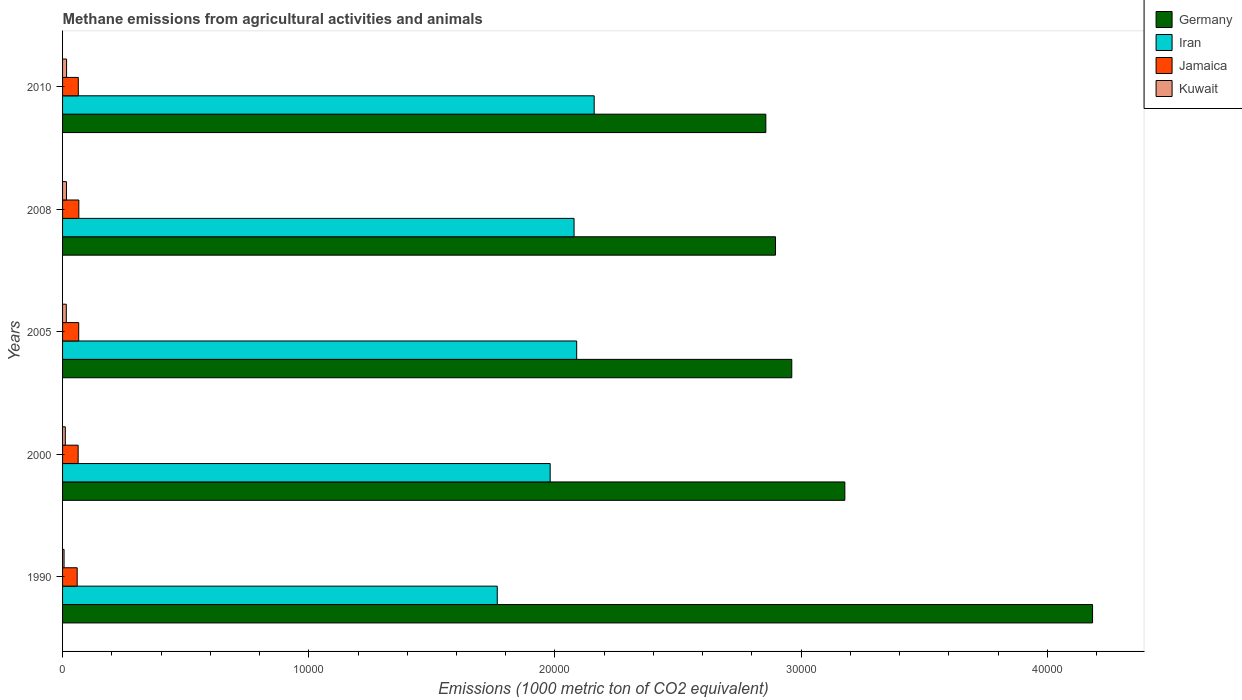Are the number of bars per tick equal to the number of legend labels?
Your response must be concise. Yes. How many bars are there on the 1st tick from the top?
Provide a short and direct response. 4. What is the amount of methane emitted in Kuwait in 2000?
Your answer should be very brief. 111.6. Across all years, what is the maximum amount of methane emitted in Germany?
Make the answer very short. 4.18e+04. Across all years, what is the minimum amount of methane emitted in Iran?
Your response must be concise. 1.77e+04. What is the total amount of methane emitted in Jamaica in the graph?
Make the answer very short. 3182.2. What is the difference between the amount of methane emitted in Iran in 1990 and that in 2000?
Give a very brief answer. -2149.4. What is the difference between the amount of methane emitted in Jamaica in 2010 and the amount of methane emitted in Kuwait in 2005?
Provide a short and direct response. 487.4. What is the average amount of methane emitted in Jamaica per year?
Provide a succinct answer. 636.44. In the year 2000, what is the difference between the amount of methane emitted in Iran and amount of methane emitted in Jamaica?
Give a very brief answer. 1.92e+04. In how many years, is the amount of methane emitted in Kuwait greater than 12000 1000 metric ton?
Give a very brief answer. 0. What is the ratio of the amount of methane emitted in Iran in 2000 to that in 2008?
Your answer should be compact. 0.95. What is the difference between the highest and the second highest amount of methane emitted in Jamaica?
Provide a short and direct response. 5.2. What is the difference between the highest and the lowest amount of methane emitted in Iran?
Your answer should be compact. 3937.1. Is the sum of the amount of methane emitted in Kuwait in 2005 and 2008 greater than the maximum amount of methane emitted in Iran across all years?
Ensure brevity in your answer.  No. Is it the case that in every year, the sum of the amount of methane emitted in Iran and amount of methane emitted in Germany is greater than the sum of amount of methane emitted in Kuwait and amount of methane emitted in Jamaica?
Your response must be concise. Yes. What does the 4th bar from the top in 1990 represents?
Offer a very short reply. Germany. What does the 1st bar from the bottom in 1990 represents?
Offer a very short reply. Germany. How many bars are there?
Provide a succinct answer. 20. Are the values on the major ticks of X-axis written in scientific E-notation?
Offer a terse response. No. Does the graph contain grids?
Offer a terse response. No. Where does the legend appear in the graph?
Ensure brevity in your answer.  Top right. What is the title of the graph?
Offer a terse response. Methane emissions from agricultural activities and animals. Does "South Asia" appear as one of the legend labels in the graph?
Your response must be concise. No. What is the label or title of the X-axis?
Your answer should be very brief. Emissions (1000 metric ton of CO2 equivalent). What is the Emissions (1000 metric ton of CO2 equivalent) of Germany in 1990?
Keep it short and to the point. 4.18e+04. What is the Emissions (1000 metric ton of CO2 equivalent) in Iran in 1990?
Your response must be concise. 1.77e+04. What is the Emissions (1000 metric ton of CO2 equivalent) in Jamaica in 1990?
Give a very brief answer. 593.6. What is the Emissions (1000 metric ton of CO2 equivalent) of Kuwait in 1990?
Provide a short and direct response. 60.5. What is the Emissions (1000 metric ton of CO2 equivalent) in Germany in 2000?
Provide a succinct answer. 3.18e+04. What is the Emissions (1000 metric ton of CO2 equivalent) in Iran in 2000?
Provide a succinct answer. 1.98e+04. What is the Emissions (1000 metric ton of CO2 equivalent) in Jamaica in 2000?
Your answer should be very brief. 632.9. What is the Emissions (1000 metric ton of CO2 equivalent) of Kuwait in 2000?
Provide a succinct answer. 111.6. What is the Emissions (1000 metric ton of CO2 equivalent) in Germany in 2005?
Provide a short and direct response. 2.96e+04. What is the Emissions (1000 metric ton of CO2 equivalent) in Iran in 2005?
Offer a very short reply. 2.09e+04. What is the Emissions (1000 metric ton of CO2 equivalent) in Jamaica in 2005?
Your answer should be compact. 655.6. What is the Emissions (1000 metric ton of CO2 equivalent) in Kuwait in 2005?
Your answer should be very brief. 151.9. What is the Emissions (1000 metric ton of CO2 equivalent) in Germany in 2008?
Give a very brief answer. 2.90e+04. What is the Emissions (1000 metric ton of CO2 equivalent) of Iran in 2008?
Ensure brevity in your answer.  2.08e+04. What is the Emissions (1000 metric ton of CO2 equivalent) in Jamaica in 2008?
Give a very brief answer. 660.8. What is the Emissions (1000 metric ton of CO2 equivalent) of Kuwait in 2008?
Offer a very short reply. 158. What is the Emissions (1000 metric ton of CO2 equivalent) in Germany in 2010?
Ensure brevity in your answer.  2.86e+04. What is the Emissions (1000 metric ton of CO2 equivalent) in Iran in 2010?
Keep it short and to the point. 2.16e+04. What is the Emissions (1000 metric ton of CO2 equivalent) of Jamaica in 2010?
Your response must be concise. 639.3. What is the Emissions (1000 metric ton of CO2 equivalent) of Kuwait in 2010?
Keep it short and to the point. 162.8. Across all years, what is the maximum Emissions (1000 metric ton of CO2 equivalent) of Germany?
Make the answer very short. 4.18e+04. Across all years, what is the maximum Emissions (1000 metric ton of CO2 equivalent) of Iran?
Keep it short and to the point. 2.16e+04. Across all years, what is the maximum Emissions (1000 metric ton of CO2 equivalent) in Jamaica?
Ensure brevity in your answer.  660.8. Across all years, what is the maximum Emissions (1000 metric ton of CO2 equivalent) in Kuwait?
Offer a terse response. 162.8. Across all years, what is the minimum Emissions (1000 metric ton of CO2 equivalent) in Germany?
Ensure brevity in your answer.  2.86e+04. Across all years, what is the minimum Emissions (1000 metric ton of CO2 equivalent) of Iran?
Offer a very short reply. 1.77e+04. Across all years, what is the minimum Emissions (1000 metric ton of CO2 equivalent) of Jamaica?
Make the answer very short. 593.6. Across all years, what is the minimum Emissions (1000 metric ton of CO2 equivalent) in Kuwait?
Offer a terse response. 60.5. What is the total Emissions (1000 metric ton of CO2 equivalent) of Germany in the graph?
Make the answer very short. 1.61e+05. What is the total Emissions (1000 metric ton of CO2 equivalent) of Iran in the graph?
Your answer should be very brief. 1.01e+05. What is the total Emissions (1000 metric ton of CO2 equivalent) of Jamaica in the graph?
Provide a succinct answer. 3182.2. What is the total Emissions (1000 metric ton of CO2 equivalent) of Kuwait in the graph?
Give a very brief answer. 644.8. What is the difference between the Emissions (1000 metric ton of CO2 equivalent) in Germany in 1990 and that in 2000?
Your answer should be very brief. 1.01e+04. What is the difference between the Emissions (1000 metric ton of CO2 equivalent) of Iran in 1990 and that in 2000?
Give a very brief answer. -2149.4. What is the difference between the Emissions (1000 metric ton of CO2 equivalent) in Jamaica in 1990 and that in 2000?
Make the answer very short. -39.3. What is the difference between the Emissions (1000 metric ton of CO2 equivalent) in Kuwait in 1990 and that in 2000?
Make the answer very short. -51.1. What is the difference between the Emissions (1000 metric ton of CO2 equivalent) of Germany in 1990 and that in 2005?
Keep it short and to the point. 1.22e+04. What is the difference between the Emissions (1000 metric ton of CO2 equivalent) of Iran in 1990 and that in 2005?
Make the answer very short. -3226.3. What is the difference between the Emissions (1000 metric ton of CO2 equivalent) in Jamaica in 1990 and that in 2005?
Make the answer very short. -62. What is the difference between the Emissions (1000 metric ton of CO2 equivalent) in Kuwait in 1990 and that in 2005?
Offer a very short reply. -91.4. What is the difference between the Emissions (1000 metric ton of CO2 equivalent) of Germany in 1990 and that in 2008?
Give a very brief answer. 1.29e+04. What is the difference between the Emissions (1000 metric ton of CO2 equivalent) in Iran in 1990 and that in 2008?
Keep it short and to the point. -3119.6. What is the difference between the Emissions (1000 metric ton of CO2 equivalent) of Jamaica in 1990 and that in 2008?
Provide a short and direct response. -67.2. What is the difference between the Emissions (1000 metric ton of CO2 equivalent) in Kuwait in 1990 and that in 2008?
Your response must be concise. -97.5. What is the difference between the Emissions (1000 metric ton of CO2 equivalent) in Germany in 1990 and that in 2010?
Offer a terse response. 1.33e+04. What is the difference between the Emissions (1000 metric ton of CO2 equivalent) of Iran in 1990 and that in 2010?
Your response must be concise. -3937.1. What is the difference between the Emissions (1000 metric ton of CO2 equivalent) in Jamaica in 1990 and that in 2010?
Give a very brief answer. -45.7. What is the difference between the Emissions (1000 metric ton of CO2 equivalent) of Kuwait in 1990 and that in 2010?
Provide a succinct answer. -102.3. What is the difference between the Emissions (1000 metric ton of CO2 equivalent) of Germany in 2000 and that in 2005?
Provide a short and direct response. 2155.4. What is the difference between the Emissions (1000 metric ton of CO2 equivalent) in Iran in 2000 and that in 2005?
Give a very brief answer. -1076.9. What is the difference between the Emissions (1000 metric ton of CO2 equivalent) in Jamaica in 2000 and that in 2005?
Your response must be concise. -22.7. What is the difference between the Emissions (1000 metric ton of CO2 equivalent) of Kuwait in 2000 and that in 2005?
Your answer should be compact. -40.3. What is the difference between the Emissions (1000 metric ton of CO2 equivalent) of Germany in 2000 and that in 2008?
Ensure brevity in your answer.  2816.4. What is the difference between the Emissions (1000 metric ton of CO2 equivalent) of Iran in 2000 and that in 2008?
Your answer should be compact. -970.2. What is the difference between the Emissions (1000 metric ton of CO2 equivalent) in Jamaica in 2000 and that in 2008?
Offer a very short reply. -27.9. What is the difference between the Emissions (1000 metric ton of CO2 equivalent) of Kuwait in 2000 and that in 2008?
Give a very brief answer. -46.4. What is the difference between the Emissions (1000 metric ton of CO2 equivalent) of Germany in 2000 and that in 2010?
Your response must be concise. 3209.1. What is the difference between the Emissions (1000 metric ton of CO2 equivalent) in Iran in 2000 and that in 2010?
Offer a very short reply. -1787.7. What is the difference between the Emissions (1000 metric ton of CO2 equivalent) of Kuwait in 2000 and that in 2010?
Provide a short and direct response. -51.2. What is the difference between the Emissions (1000 metric ton of CO2 equivalent) of Germany in 2005 and that in 2008?
Offer a terse response. 661. What is the difference between the Emissions (1000 metric ton of CO2 equivalent) of Iran in 2005 and that in 2008?
Offer a terse response. 106.7. What is the difference between the Emissions (1000 metric ton of CO2 equivalent) in Jamaica in 2005 and that in 2008?
Offer a terse response. -5.2. What is the difference between the Emissions (1000 metric ton of CO2 equivalent) in Germany in 2005 and that in 2010?
Your response must be concise. 1053.7. What is the difference between the Emissions (1000 metric ton of CO2 equivalent) of Iran in 2005 and that in 2010?
Provide a short and direct response. -710.8. What is the difference between the Emissions (1000 metric ton of CO2 equivalent) in Jamaica in 2005 and that in 2010?
Make the answer very short. 16.3. What is the difference between the Emissions (1000 metric ton of CO2 equivalent) in Germany in 2008 and that in 2010?
Provide a succinct answer. 392.7. What is the difference between the Emissions (1000 metric ton of CO2 equivalent) of Iran in 2008 and that in 2010?
Your response must be concise. -817.5. What is the difference between the Emissions (1000 metric ton of CO2 equivalent) of Kuwait in 2008 and that in 2010?
Provide a short and direct response. -4.8. What is the difference between the Emissions (1000 metric ton of CO2 equivalent) in Germany in 1990 and the Emissions (1000 metric ton of CO2 equivalent) in Iran in 2000?
Keep it short and to the point. 2.20e+04. What is the difference between the Emissions (1000 metric ton of CO2 equivalent) in Germany in 1990 and the Emissions (1000 metric ton of CO2 equivalent) in Jamaica in 2000?
Offer a very short reply. 4.12e+04. What is the difference between the Emissions (1000 metric ton of CO2 equivalent) of Germany in 1990 and the Emissions (1000 metric ton of CO2 equivalent) of Kuwait in 2000?
Your answer should be compact. 4.17e+04. What is the difference between the Emissions (1000 metric ton of CO2 equivalent) in Iran in 1990 and the Emissions (1000 metric ton of CO2 equivalent) in Jamaica in 2000?
Ensure brevity in your answer.  1.70e+04. What is the difference between the Emissions (1000 metric ton of CO2 equivalent) of Iran in 1990 and the Emissions (1000 metric ton of CO2 equivalent) of Kuwait in 2000?
Provide a succinct answer. 1.75e+04. What is the difference between the Emissions (1000 metric ton of CO2 equivalent) of Jamaica in 1990 and the Emissions (1000 metric ton of CO2 equivalent) of Kuwait in 2000?
Provide a succinct answer. 482. What is the difference between the Emissions (1000 metric ton of CO2 equivalent) of Germany in 1990 and the Emissions (1000 metric ton of CO2 equivalent) of Iran in 2005?
Offer a terse response. 2.10e+04. What is the difference between the Emissions (1000 metric ton of CO2 equivalent) in Germany in 1990 and the Emissions (1000 metric ton of CO2 equivalent) in Jamaica in 2005?
Offer a very short reply. 4.12e+04. What is the difference between the Emissions (1000 metric ton of CO2 equivalent) of Germany in 1990 and the Emissions (1000 metric ton of CO2 equivalent) of Kuwait in 2005?
Keep it short and to the point. 4.17e+04. What is the difference between the Emissions (1000 metric ton of CO2 equivalent) in Iran in 1990 and the Emissions (1000 metric ton of CO2 equivalent) in Jamaica in 2005?
Give a very brief answer. 1.70e+04. What is the difference between the Emissions (1000 metric ton of CO2 equivalent) of Iran in 1990 and the Emissions (1000 metric ton of CO2 equivalent) of Kuwait in 2005?
Provide a short and direct response. 1.75e+04. What is the difference between the Emissions (1000 metric ton of CO2 equivalent) of Jamaica in 1990 and the Emissions (1000 metric ton of CO2 equivalent) of Kuwait in 2005?
Ensure brevity in your answer.  441.7. What is the difference between the Emissions (1000 metric ton of CO2 equivalent) of Germany in 1990 and the Emissions (1000 metric ton of CO2 equivalent) of Iran in 2008?
Your answer should be very brief. 2.11e+04. What is the difference between the Emissions (1000 metric ton of CO2 equivalent) in Germany in 1990 and the Emissions (1000 metric ton of CO2 equivalent) in Jamaica in 2008?
Provide a succinct answer. 4.12e+04. What is the difference between the Emissions (1000 metric ton of CO2 equivalent) of Germany in 1990 and the Emissions (1000 metric ton of CO2 equivalent) of Kuwait in 2008?
Ensure brevity in your answer.  4.17e+04. What is the difference between the Emissions (1000 metric ton of CO2 equivalent) in Iran in 1990 and the Emissions (1000 metric ton of CO2 equivalent) in Jamaica in 2008?
Give a very brief answer. 1.70e+04. What is the difference between the Emissions (1000 metric ton of CO2 equivalent) of Iran in 1990 and the Emissions (1000 metric ton of CO2 equivalent) of Kuwait in 2008?
Your answer should be very brief. 1.75e+04. What is the difference between the Emissions (1000 metric ton of CO2 equivalent) of Jamaica in 1990 and the Emissions (1000 metric ton of CO2 equivalent) of Kuwait in 2008?
Offer a terse response. 435.6. What is the difference between the Emissions (1000 metric ton of CO2 equivalent) in Germany in 1990 and the Emissions (1000 metric ton of CO2 equivalent) in Iran in 2010?
Provide a succinct answer. 2.02e+04. What is the difference between the Emissions (1000 metric ton of CO2 equivalent) in Germany in 1990 and the Emissions (1000 metric ton of CO2 equivalent) in Jamaica in 2010?
Your answer should be very brief. 4.12e+04. What is the difference between the Emissions (1000 metric ton of CO2 equivalent) of Germany in 1990 and the Emissions (1000 metric ton of CO2 equivalent) of Kuwait in 2010?
Make the answer very short. 4.17e+04. What is the difference between the Emissions (1000 metric ton of CO2 equivalent) of Iran in 1990 and the Emissions (1000 metric ton of CO2 equivalent) of Jamaica in 2010?
Make the answer very short. 1.70e+04. What is the difference between the Emissions (1000 metric ton of CO2 equivalent) of Iran in 1990 and the Emissions (1000 metric ton of CO2 equivalent) of Kuwait in 2010?
Make the answer very short. 1.75e+04. What is the difference between the Emissions (1000 metric ton of CO2 equivalent) in Jamaica in 1990 and the Emissions (1000 metric ton of CO2 equivalent) in Kuwait in 2010?
Offer a terse response. 430.8. What is the difference between the Emissions (1000 metric ton of CO2 equivalent) of Germany in 2000 and the Emissions (1000 metric ton of CO2 equivalent) of Iran in 2005?
Provide a succinct answer. 1.09e+04. What is the difference between the Emissions (1000 metric ton of CO2 equivalent) of Germany in 2000 and the Emissions (1000 metric ton of CO2 equivalent) of Jamaica in 2005?
Provide a short and direct response. 3.11e+04. What is the difference between the Emissions (1000 metric ton of CO2 equivalent) in Germany in 2000 and the Emissions (1000 metric ton of CO2 equivalent) in Kuwait in 2005?
Provide a short and direct response. 3.16e+04. What is the difference between the Emissions (1000 metric ton of CO2 equivalent) in Iran in 2000 and the Emissions (1000 metric ton of CO2 equivalent) in Jamaica in 2005?
Offer a terse response. 1.91e+04. What is the difference between the Emissions (1000 metric ton of CO2 equivalent) of Iran in 2000 and the Emissions (1000 metric ton of CO2 equivalent) of Kuwait in 2005?
Ensure brevity in your answer.  1.97e+04. What is the difference between the Emissions (1000 metric ton of CO2 equivalent) in Jamaica in 2000 and the Emissions (1000 metric ton of CO2 equivalent) in Kuwait in 2005?
Give a very brief answer. 481. What is the difference between the Emissions (1000 metric ton of CO2 equivalent) of Germany in 2000 and the Emissions (1000 metric ton of CO2 equivalent) of Iran in 2008?
Provide a short and direct response. 1.10e+04. What is the difference between the Emissions (1000 metric ton of CO2 equivalent) in Germany in 2000 and the Emissions (1000 metric ton of CO2 equivalent) in Jamaica in 2008?
Your response must be concise. 3.11e+04. What is the difference between the Emissions (1000 metric ton of CO2 equivalent) in Germany in 2000 and the Emissions (1000 metric ton of CO2 equivalent) in Kuwait in 2008?
Give a very brief answer. 3.16e+04. What is the difference between the Emissions (1000 metric ton of CO2 equivalent) in Iran in 2000 and the Emissions (1000 metric ton of CO2 equivalent) in Jamaica in 2008?
Make the answer very short. 1.91e+04. What is the difference between the Emissions (1000 metric ton of CO2 equivalent) in Iran in 2000 and the Emissions (1000 metric ton of CO2 equivalent) in Kuwait in 2008?
Ensure brevity in your answer.  1.96e+04. What is the difference between the Emissions (1000 metric ton of CO2 equivalent) of Jamaica in 2000 and the Emissions (1000 metric ton of CO2 equivalent) of Kuwait in 2008?
Offer a terse response. 474.9. What is the difference between the Emissions (1000 metric ton of CO2 equivalent) in Germany in 2000 and the Emissions (1000 metric ton of CO2 equivalent) in Iran in 2010?
Keep it short and to the point. 1.02e+04. What is the difference between the Emissions (1000 metric ton of CO2 equivalent) of Germany in 2000 and the Emissions (1000 metric ton of CO2 equivalent) of Jamaica in 2010?
Keep it short and to the point. 3.11e+04. What is the difference between the Emissions (1000 metric ton of CO2 equivalent) in Germany in 2000 and the Emissions (1000 metric ton of CO2 equivalent) in Kuwait in 2010?
Give a very brief answer. 3.16e+04. What is the difference between the Emissions (1000 metric ton of CO2 equivalent) of Iran in 2000 and the Emissions (1000 metric ton of CO2 equivalent) of Jamaica in 2010?
Keep it short and to the point. 1.92e+04. What is the difference between the Emissions (1000 metric ton of CO2 equivalent) of Iran in 2000 and the Emissions (1000 metric ton of CO2 equivalent) of Kuwait in 2010?
Ensure brevity in your answer.  1.96e+04. What is the difference between the Emissions (1000 metric ton of CO2 equivalent) of Jamaica in 2000 and the Emissions (1000 metric ton of CO2 equivalent) of Kuwait in 2010?
Keep it short and to the point. 470.1. What is the difference between the Emissions (1000 metric ton of CO2 equivalent) in Germany in 2005 and the Emissions (1000 metric ton of CO2 equivalent) in Iran in 2008?
Your response must be concise. 8842.7. What is the difference between the Emissions (1000 metric ton of CO2 equivalent) in Germany in 2005 and the Emissions (1000 metric ton of CO2 equivalent) in Jamaica in 2008?
Keep it short and to the point. 2.90e+04. What is the difference between the Emissions (1000 metric ton of CO2 equivalent) in Germany in 2005 and the Emissions (1000 metric ton of CO2 equivalent) in Kuwait in 2008?
Offer a very short reply. 2.95e+04. What is the difference between the Emissions (1000 metric ton of CO2 equivalent) of Iran in 2005 and the Emissions (1000 metric ton of CO2 equivalent) of Jamaica in 2008?
Make the answer very short. 2.02e+04. What is the difference between the Emissions (1000 metric ton of CO2 equivalent) of Iran in 2005 and the Emissions (1000 metric ton of CO2 equivalent) of Kuwait in 2008?
Keep it short and to the point. 2.07e+04. What is the difference between the Emissions (1000 metric ton of CO2 equivalent) in Jamaica in 2005 and the Emissions (1000 metric ton of CO2 equivalent) in Kuwait in 2008?
Make the answer very short. 497.6. What is the difference between the Emissions (1000 metric ton of CO2 equivalent) in Germany in 2005 and the Emissions (1000 metric ton of CO2 equivalent) in Iran in 2010?
Keep it short and to the point. 8025.2. What is the difference between the Emissions (1000 metric ton of CO2 equivalent) of Germany in 2005 and the Emissions (1000 metric ton of CO2 equivalent) of Jamaica in 2010?
Ensure brevity in your answer.  2.90e+04. What is the difference between the Emissions (1000 metric ton of CO2 equivalent) of Germany in 2005 and the Emissions (1000 metric ton of CO2 equivalent) of Kuwait in 2010?
Provide a short and direct response. 2.95e+04. What is the difference between the Emissions (1000 metric ton of CO2 equivalent) of Iran in 2005 and the Emissions (1000 metric ton of CO2 equivalent) of Jamaica in 2010?
Keep it short and to the point. 2.02e+04. What is the difference between the Emissions (1000 metric ton of CO2 equivalent) of Iran in 2005 and the Emissions (1000 metric ton of CO2 equivalent) of Kuwait in 2010?
Give a very brief answer. 2.07e+04. What is the difference between the Emissions (1000 metric ton of CO2 equivalent) in Jamaica in 2005 and the Emissions (1000 metric ton of CO2 equivalent) in Kuwait in 2010?
Offer a very short reply. 492.8. What is the difference between the Emissions (1000 metric ton of CO2 equivalent) in Germany in 2008 and the Emissions (1000 metric ton of CO2 equivalent) in Iran in 2010?
Make the answer very short. 7364.2. What is the difference between the Emissions (1000 metric ton of CO2 equivalent) in Germany in 2008 and the Emissions (1000 metric ton of CO2 equivalent) in Jamaica in 2010?
Your answer should be compact. 2.83e+04. What is the difference between the Emissions (1000 metric ton of CO2 equivalent) in Germany in 2008 and the Emissions (1000 metric ton of CO2 equivalent) in Kuwait in 2010?
Provide a succinct answer. 2.88e+04. What is the difference between the Emissions (1000 metric ton of CO2 equivalent) of Iran in 2008 and the Emissions (1000 metric ton of CO2 equivalent) of Jamaica in 2010?
Ensure brevity in your answer.  2.01e+04. What is the difference between the Emissions (1000 metric ton of CO2 equivalent) in Iran in 2008 and the Emissions (1000 metric ton of CO2 equivalent) in Kuwait in 2010?
Offer a very short reply. 2.06e+04. What is the difference between the Emissions (1000 metric ton of CO2 equivalent) of Jamaica in 2008 and the Emissions (1000 metric ton of CO2 equivalent) of Kuwait in 2010?
Make the answer very short. 498. What is the average Emissions (1000 metric ton of CO2 equivalent) of Germany per year?
Make the answer very short. 3.21e+04. What is the average Emissions (1000 metric ton of CO2 equivalent) in Iran per year?
Your answer should be very brief. 2.01e+04. What is the average Emissions (1000 metric ton of CO2 equivalent) in Jamaica per year?
Keep it short and to the point. 636.44. What is the average Emissions (1000 metric ton of CO2 equivalent) of Kuwait per year?
Ensure brevity in your answer.  128.96. In the year 1990, what is the difference between the Emissions (1000 metric ton of CO2 equivalent) in Germany and Emissions (1000 metric ton of CO2 equivalent) in Iran?
Make the answer very short. 2.42e+04. In the year 1990, what is the difference between the Emissions (1000 metric ton of CO2 equivalent) in Germany and Emissions (1000 metric ton of CO2 equivalent) in Jamaica?
Ensure brevity in your answer.  4.12e+04. In the year 1990, what is the difference between the Emissions (1000 metric ton of CO2 equivalent) of Germany and Emissions (1000 metric ton of CO2 equivalent) of Kuwait?
Ensure brevity in your answer.  4.18e+04. In the year 1990, what is the difference between the Emissions (1000 metric ton of CO2 equivalent) in Iran and Emissions (1000 metric ton of CO2 equivalent) in Jamaica?
Your answer should be compact. 1.71e+04. In the year 1990, what is the difference between the Emissions (1000 metric ton of CO2 equivalent) of Iran and Emissions (1000 metric ton of CO2 equivalent) of Kuwait?
Offer a very short reply. 1.76e+04. In the year 1990, what is the difference between the Emissions (1000 metric ton of CO2 equivalent) in Jamaica and Emissions (1000 metric ton of CO2 equivalent) in Kuwait?
Make the answer very short. 533.1. In the year 2000, what is the difference between the Emissions (1000 metric ton of CO2 equivalent) in Germany and Emissions (1000 metric ton of CO2 equivalent) in Iran?
Your response must be concise. 1.20e+04. In the year 2000, what is the difference between the Emissions (1000 metric ton of CO2 equivalent) in Germany and Emissions (1000 metric ton of CO2 equivalent) in Jamaica?
Provide a short and direct response. 3.11e+04. In the year 2000, what is the difference between the Emissions (1000 metric ton of CO2 equivalent) of Germany and Emissions (1000 metric ton of CO2 equivalent) of Kuwait?
Give a very brief answer. 3.17e+04. In the year 2000, what is the difference between the Emissions (1000 metric ton of CO2 equivalent) in Iran and Emissions (1000 metric ton of CO2 equivalent) in Jamaica?
Keep it short and to the point. 1.92e+04. In the year 2000, what is the difference between the Emissions (1000 metric ton of CO2 equivalent) in Iran and Emissions (1000 metric ton of CO2 equivalent) in Kuwait?
Provide a succinct answer. 1.97e+04. In the year 2000, what is the difference between the Emissions (1000 metric ton of CO2 equivalent) of Jamaica and Emissions (1000 metric ton of CO2 equivalent) of Kuwait?
Offer a terse response. 521.3. In the year 2005, what is the difference between the Emissions (1000 metric ton of CO2 equivalent) of Germany and Emissions (1000 metric ton of CO2 equivalent) of Iran?
Provide a short and direct response. 8736. In the year 2005, what is the difference between the Emissions (1000 metric ton of CO2 equivalent) of Germany and Emissions (1000 metric ton of CO2 equivalent) of Jamaica?
Give a very brief answer. 2.90e+04. In the year 2005, what is the difference between the Emissions (1000 metric ton of CO2 equivalent) in Germany and Emissions (1000 metric ton of CO2 equivalent) in Kuwait?
Offer a very short reply. 2.95e+04. In the year 2005, what is the difference between the Emissions (1000 metric ton of CO2 equivalent) in Iran and Emissions (1000 metric ton of CO2 equivalent) in Jamaica?
Give a very brief answer. 2.02e+04. In the year 2005, what is the difference between the Emissions (1000 metric ton of CO2 equivalent) in Iran and Emissions (1000 metric ton of CO2 equivalent) in Kuwait?
Keep it short and to the point. 2.07e+04. In the year 2005, what is the difference between the Emissions (1000 metric ton of CO2 equivalent) of Jamaica and Emissions (1000 metric ton of CO2 equivalent) of Kuwait?
Your response must be concise. 503.7. In the year 2008, what is the difference between the Emissions (1000 metric ton of CO2 equivalent) in Germany and Emissions (1000 metric ton of CO2 equivalent) in Iran?
Ensure brevity in your answer.  8181.7. In the year 2008, what is the difference between the Emissions (1000 metric ton of CO2 equivalent) of Germany and Emissions (1000 metric ton of CO2 equivalent) of Jamaica?
Provide a succinct answer. 2.83e+04. In the year 2008, what is the difference between the Emissions (1000 metric ton of CO2 equivalent) of Germany and Emissions (1000 metric ton of CO2 equivalent) of Kuwait?
Ensure brevity in your answer.  2.88e+04. In the year 2008, what is the difference between the Emissions (1000 metric ton of CO2 equivalent) of Iran and Emissions (1000 metric ton of CO2 equivalent) of Jamaica?
Make the answer very short. 2.01e+04. In the year 2008, what is the difference between the Emissions (1000 metric ton of CO2 equivalent) of Iran and Emissions (1000 metric ton of CO2 equivalent) of Kuwait?
Your answer should be very brief. 2.06e+04. In the year 2008, what is the difference between the Emissions (1000 metric ton of CO2 equivalent) of Jamaica and Emissions (1000 metric ton of CO2 equivalent) of Kuwait?
Your answer should be compact. 502.8. In the year 2010, what is the difference between the Emissions (1000 metric ton of CO2 equivalent) in Germany and Emissions (1000 metric ton of CO2 equivalent) in Iran?
Provide a short and direct response. 6971.5. In the year 2010, what is the difference between the Emissions (1000 metric ton of CO2 equivalent) of Germany and Emissions (1000 metric ton of CO2 equivalent) of Jamaica?
Your answer should be very brief. 2.79e+04. In the year 2010, what is the difference between the Emissions (1000 metric ton of CO2 equivalent) in Germany and Emissions (1000 metric ton of CO2 equivalent) in Kuwait?
Offer a very short reply. 2.84e+04. In the year 2010, what is the difference between the Emissions (1000 metric ton of CO2 equivalent) in Iran and Emissions (1000 metric ton of CO2 equivalent) in Jamaica?
Your response must be concise. 2.10e+04. In the year 2010, what is the difference between the Emissions (1000 metric ton of CO2 equivalent) of Iran and Emissions (1000 metric ton of CO2 equivalent) of Kuwait?
Your response must be concise. 2.14e+04. In the year 2010, what is the difference between the Emissions (1000 metric ton of CO2 equivalent) in Jamaica and Emissions (1000 metric ton of CO2 equivalent) in Kuwait?
Provide a succinct answer. 476.5. What is the ratio of the Emissions (1000 metric ton of CO2 equivalent) of Germany in 1990 to that in 2000?
Your answer should be very brief. 1.32. What is the ratio of the Emissions (1000 metric ton of CO2 equivalent) of Iran in 1990 to that in 2000?
Your answer should be very brief. 0.89. What is the ratio of the Emissions (1000 metric ton of CO2 equivalent) in Jamaica in 1990 to that in 2000?
Provide a succinct answer. 0.94. What is the ratio of the Emissions (1000 metric ton of CO2 equivalent) in Kuwait in 1990 to that in 2000?
Keep it short and to the point. 0.54. What is the ratio of the Emissions (1000 metric ton of CO2 equivalent) in Germany in 1990 to that in 2005?
Provide a short and direct response. 1.41. What is the ratio of the Emissions (1000 metric ton of CO2 equivalent) in Iran in 1990 to that in 2005?
Keep it short and to the point. 0.85. What is the ratio of the Emissions (1000 metric ton of CO2 equivalent) of Jamaica in 1990 to that in 2005?
Ensure brevity in your answer.  0.91. What is the ratio of the Emissions (1000 metric ton of CO2 equivalent) in Kuwait in 1990 to that in 2005?
Keep it short and to the point. 0.4. What is the ratio of the Emissions (1000 metric ton of CO2 equivalent) of Germany in 1990 to that in 2008?
Your answer should be compact. 1.44. What is the ratio of the Emissions (1000 metric ton of CO2 equivalent) of Iran in 1990 to that in 2008?
Ensure brevity in your answer.  0.85. What is the ratio of the Emissions (1000 metric ton of CO2 equivalent) in Jamaica in 1990 to that in 2008?
Your response must be concise. 0.9. What is the ratio of the Emissions (1000 metric ton of CO2 equivalent) of Kuwait in 1990 to that in 2008?
Provide a short and direct response. 0.38. What is the ratio of the Emissions (1000 metric ton of CO2 equivalent) in Germany in 1990 to that in 2010?
Keep it short and to the point. 1.46. What is the ratio of the Emissions (1000 metric ton of CO2 equivalent) in Iran in 1990 to that in 2010?
Your response must be concise. 0.82. What is the ratio of the Emissions (1000 metric ton of CO2 equivalent) of Jamaica in 1990 to that in 2010?
Offer a terse response. 0.93. What is the ratio of the Emissions (1000 metric ton of CO2 equivalent) of Kuwait in 1990 to that in 2010?
Provide a succinct answer. 0.37. What is the ratio of the Emissions (1000 metric ton of CO2 equivalent) of Germany in 2000 to that in 2005?
Keep it short and to the point. 1.07. What is the ratio of the Emissions (1000 metric ton of CO2 equivalent) of Iran in 2000 to that in 2005?
Offer a very short reply. 0.95. What is the ratio of the Emissions (1000 metric ton of CO2 equivalent) in Jamaica in 2000 to that in 2005?
Your answer should be very brief. 0.97. What is the ratio of the Emissions (1000 metric ton of CO2 equivalent) of Kuwait in 2000 to that in 2005?
Ensure brevity in your answer.  0.73. What is the ratio of the Emissions (1000 metric ton of CO2 equivalent) in Germany in 2000 to that in 2008?
Offer a very short reply. 1.1. What is the ratio of the Emissions (1000 metric ton of CO2 equivalent) in Iran in 2000 to that in 2008?
Offer a very short reply. 0.95. What is the ratio of the Emissions (1000 metric ton of CO2 equivalent) in Jamaica in 2000 to that in 2008?
Make the answer very short. 0.96. What is the ratio of the Emissions (1000 metric ton of CO2 equivalent) of Kuwait in 2000 to that in 2008?
Your answer should be very brief. 0.71. What is the ratio of the Emissions (1000 metric ton of CO2 equivalent) of Germany in 2000 to that in 2010?
Keep it short and to the point. 1.11. What is the ratio of the Emissions (1000 metric ton of CO2 equivalent) in Iran in 2000 to that in 2010?
Give a very brief answer. 0.92. What is the ratio of the Emissions (1000 metric ton of CO2 equivalent) in Jamaica in 2000 to that in 2010?
Offer a very short reply. 0.99. What is the ratio of the Emissions (1000 metric ton of CO2 equivalent) in Kuwait in 2000 to that in 2010?
Provide a short and direct response. 0.69. What is the ratio of the Emissions (1000 metric ton of CO2 equivalent) of Germany in 2005 to that in 2008?
Provide a short and direct response. 1.02. What is the ratio of the Emissions (1000 metric ton of CO2 equivalent) of Jamaica in 2005 to that in 2008?
Your answer should be compact. 0.99. What is the ratio of the Emissions (1000 metric ton of CO2 equivalent) in Kuwait in 2005 to that in 2008?
Your answer should be very brief. 0.96. What is the ratio of the Emissions (1000 metric ton of CO2 equivalent) of Germany in 2005 to that in 2010?
Offer a very short reply. 1.04. What is the ratio of the Emissions (1000 metric ton of CO2 equivalent) of Iran in 2005 to that in 2010?
Your response must be concise. 0.97. What is the ratio of the Emissions (1000 metric ton of CO2 equivalent) in Jamaica in 2005 to that in 2010?
Ensure brevity in your answer.  1.03. What is the ratio of the Emissions (1000 metric ton of CO2 equivalent) in Kuwait in 2005 to that in 2010?
Offer a terse response. 0.93. What is the ratio of the Emissions (1000 metric ton of CO2 equivalent) of Germany in 2008 to that in 2010?
Give a very brief answer. 1.01. What is the ratio of the Emissions (1000 metric ton of CO2 equivalent) of Iran in 2008 to that in 2010?
Give a very brief answer. 0.96. What is the ratio of the Emissions (1000 metric ton of CO2 equivalent) in Jamaica in 2008 to that in 2010?
Give a very brief answer. 1.03. What is the ratio of the Emissions (1000 metric ton of CO2 equivalent) of Kuwait in 2008 to that in 2010?
Offer a very short reply. 0.97. What is the difference between the highest and the second highest Emissions (1000 metric ton of CO2 equivalent) in Germany?
Provide a succinct answer. 1.01e+04. What is the difference between the highest and the second highest Emissions (1000 metric ton of CO2 equivalent) of Iran?
Offer a terse response. 710.8. What is the difference between the highest and the lowest Emissions (1000 metric ton of CO2 equivalent) of Germany?
Your answer should be compact. 1.33e+04. What is the difference between the highest and the lowest Emissions (1000 metric ton of CO2 equivalent) in Iran?
Ensure brevity in your answer.  3937.1. What is the difference between the highest and the lowest Emissions (1000 metric ton of CO2 equivalent) in Jamaica?
Keep it short and to the point. 67.2. What is the difference between the highest and the lowest Emissions (1000 metric ton of CO2 equivalent) of Kuwait?
Your response must be concise. 102.3. 